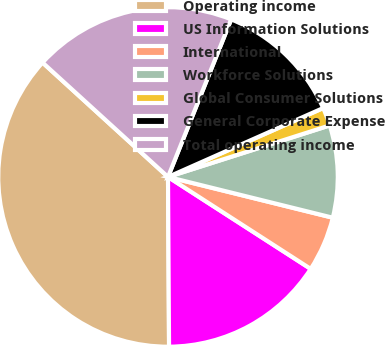<chart> <loc_0><loc_0><loc_500><loc_500><pie_chart><fcel>Operating income<fcel>US Information Solutions<fcel>International<fcel>Workforce Solutions<fcel>Global Consumer Solutions<fcel>General Corporate Expense<fcel>Total operating income<nl><fcel>36.86%<fcel>15.79%<fcel>5.25%<fcel>8.77%<fcel>1.74%<fcel>12.28%<fcel>19.3%<nl></chart> 